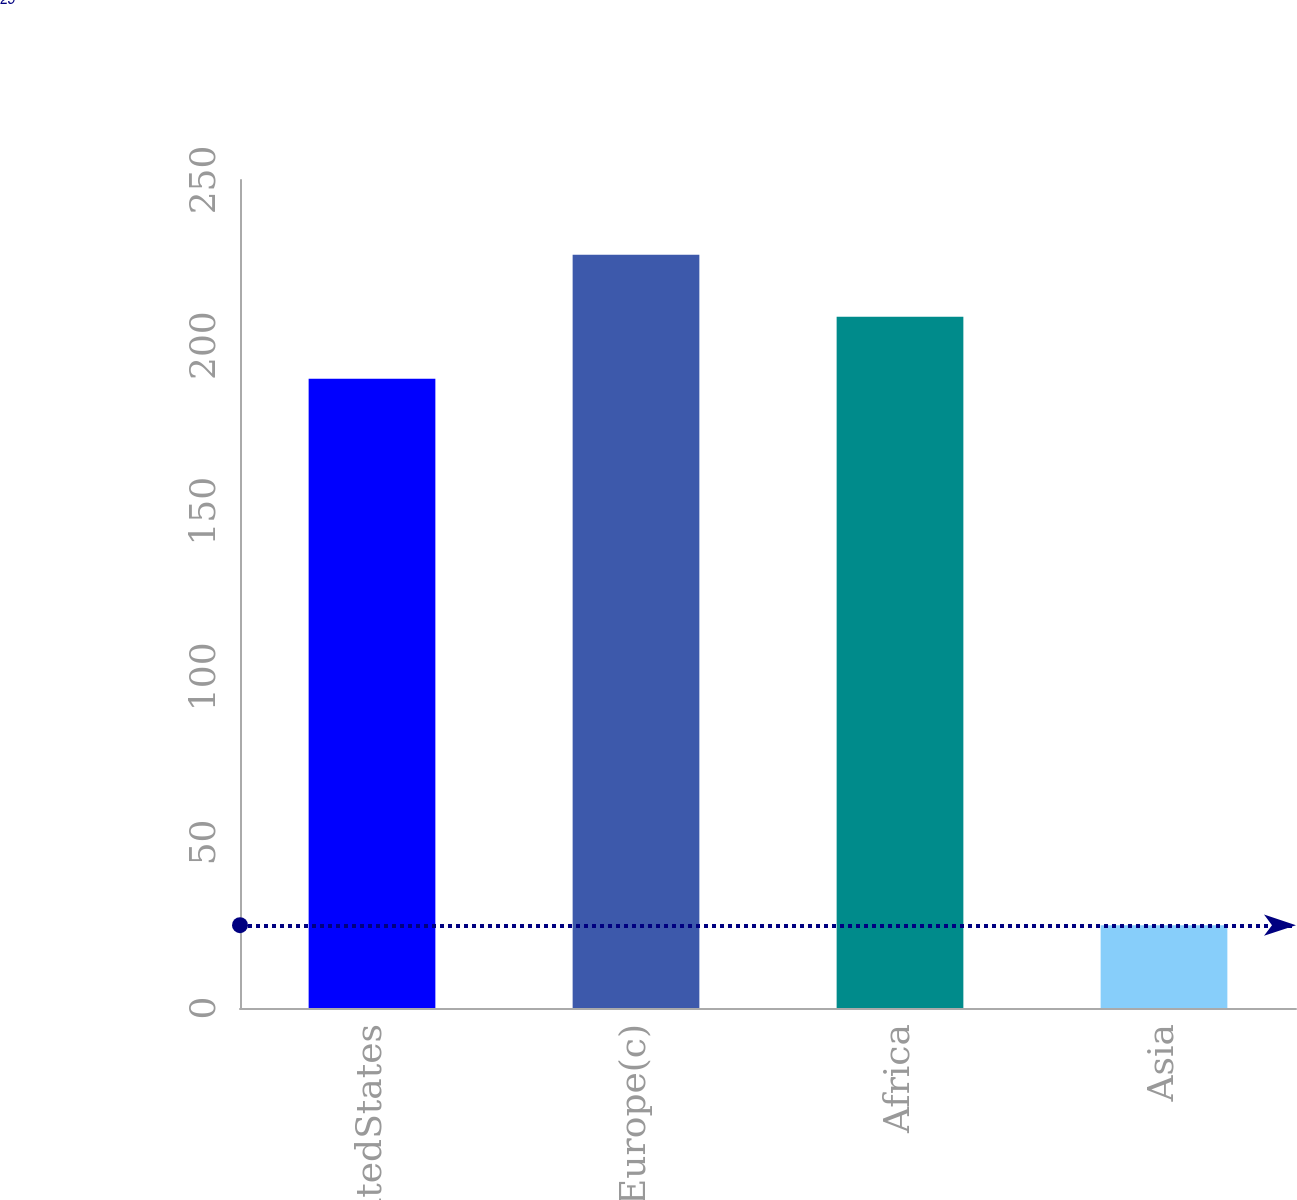Convert chart to OTSL. <chart><loc_0><loc_0><loc_500><loc_500><bar_chart><fcel>UnitedStates<fcel>Europe(c)<fcel>Africa<fcel>Asia<nl><fcel>190<fcel>227.4<fcel>208.7<fcel>25<nl></chart> 